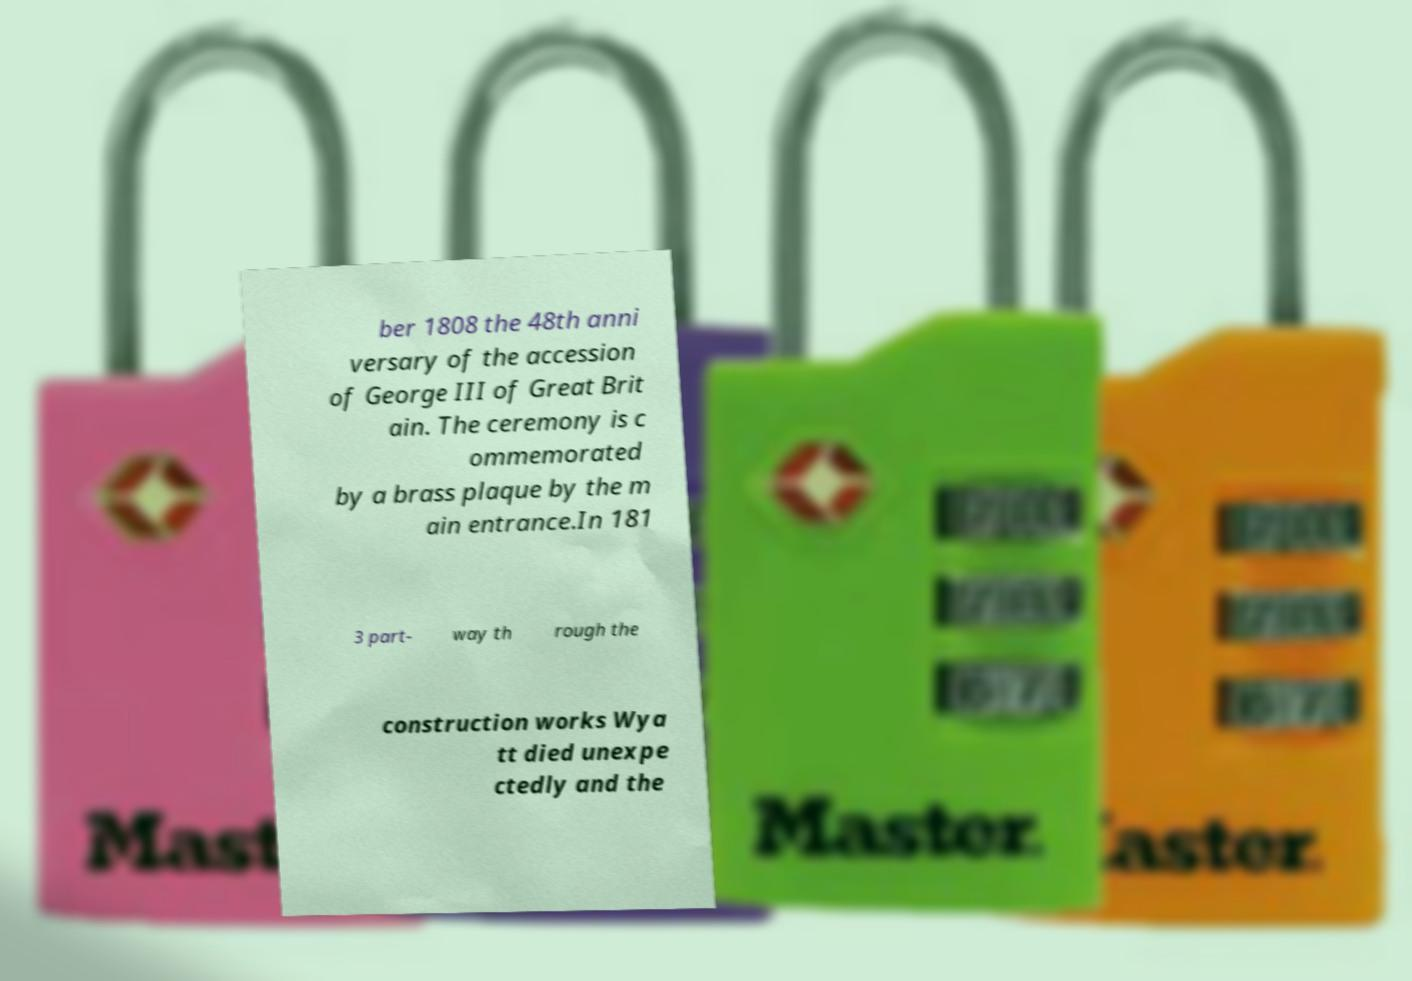Could you assist in decoding the text presented in this image and type it out clearly? ber 1808 the 48th anni versary of the accession of George III of Great Brit ain. The ceremony is c ommemorated by a brass plaque by the m ain entrance.In 181 3 part- way th rough the construction works Wya tt died unexpe ctedly and the 